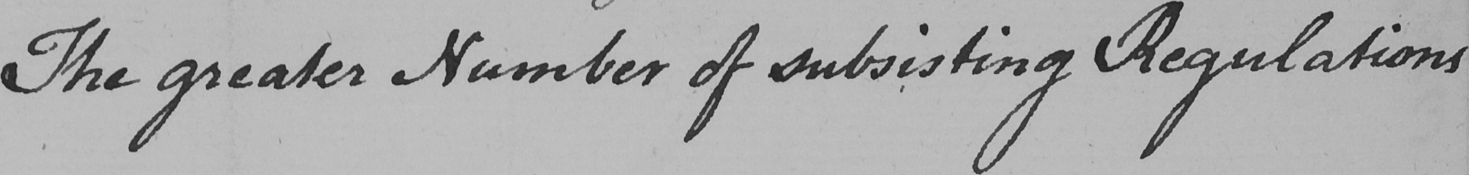Can you tell me what this handwritten text says? The greater Number of subsisting Regulations 